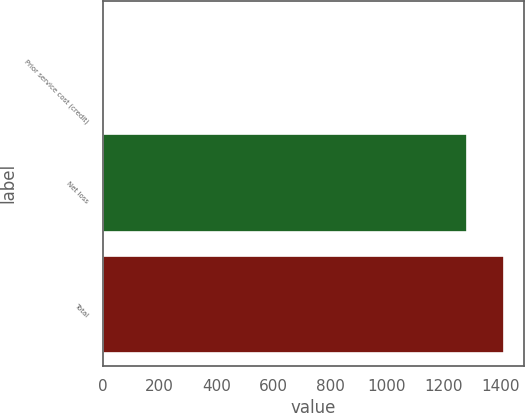Convert chart. <chart><loc_0><loc_0><loc_500><loc_500><bar_chart><fcel>Prior service cost (credit)<fcel>Net loss<fcel>Total<nl><fcel>3<fcel>1282<fcel>1410.2<nl></chart> 